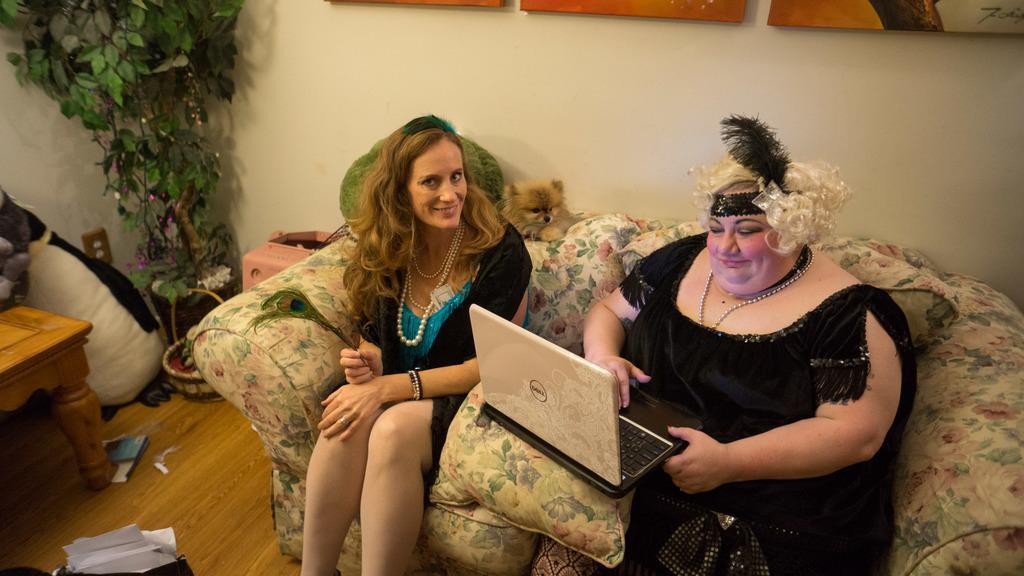In one or two sentences, can you explain what this image depicts? In this image I can see two women wearing black colored dresses are sitting on a couch which is cream and green in color. I can see a woman is holding a laptop in her hand. I can see few papers in the bag, a brown colored table, pink colored object, a tree, a cream colored wall and few photo frames attached to the wall. 